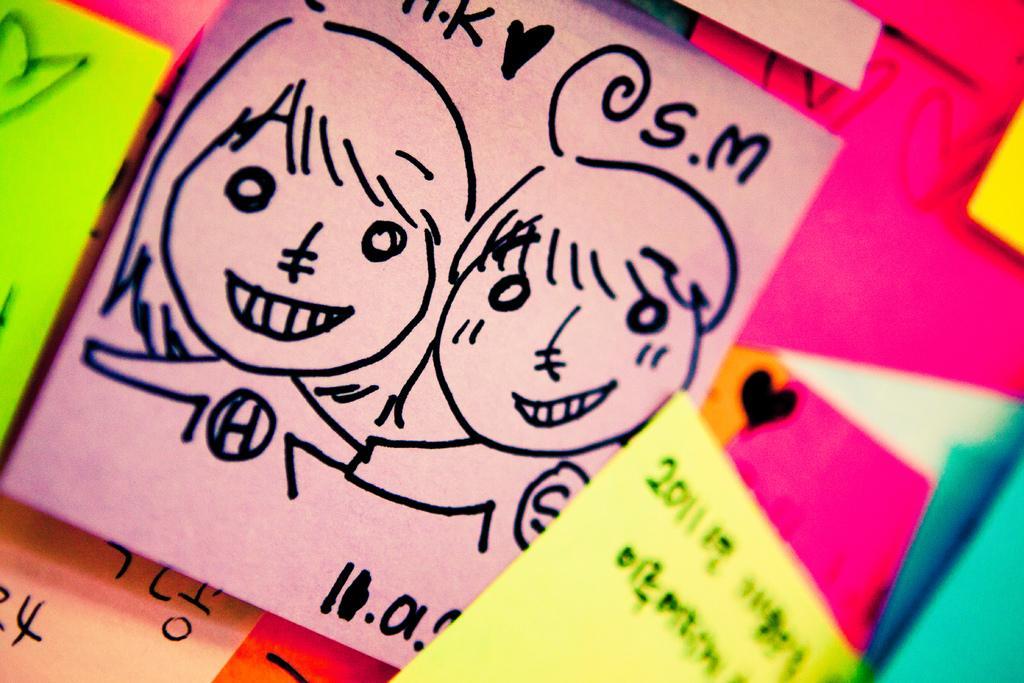Please provide a concise description of this image. In this picture I can see the papers on the wall. In the center I can see the design of a woman. 